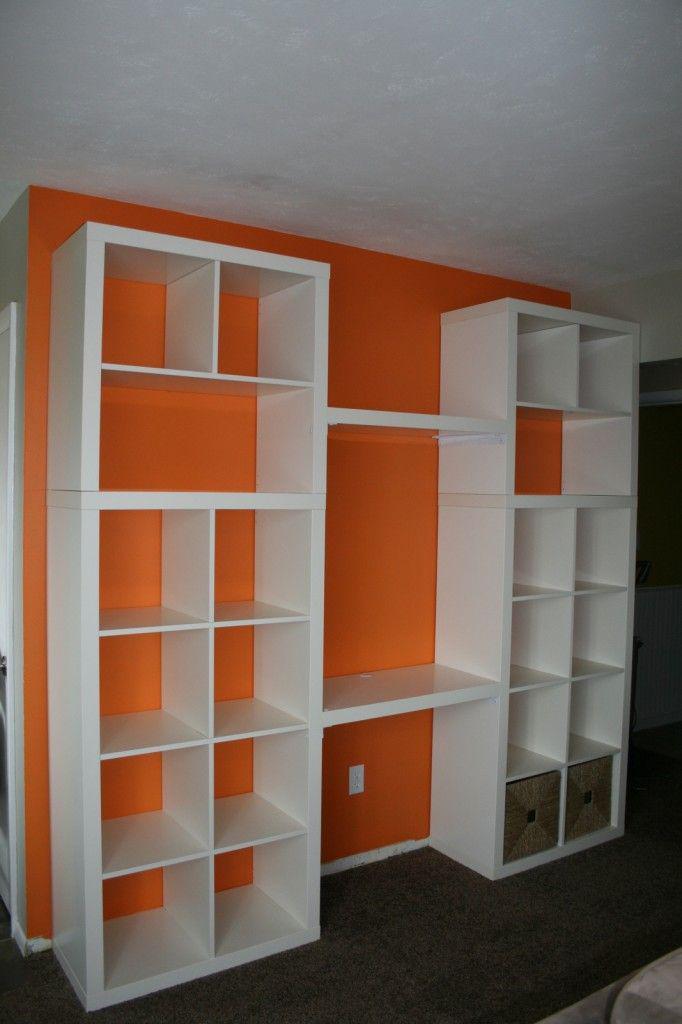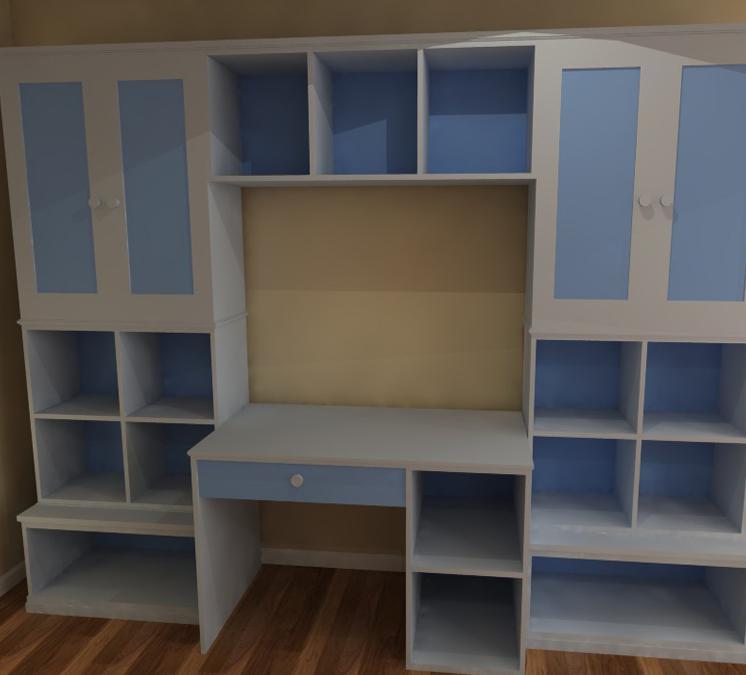The first image is the image on the left, the second image is the image on the right. Analyze the images presented: Is the assertion "An image shows a white bookcase unit in front of a bright orange divider wall." valid? Answer yes or no. Yes. The first image is the image on the left, the second image is the image on the right. Examine the images to the left and right. Is the description "In one of the images, there are built in bookcases attached to a bright orange wall." accurate? Answer yes or no. Yes. 